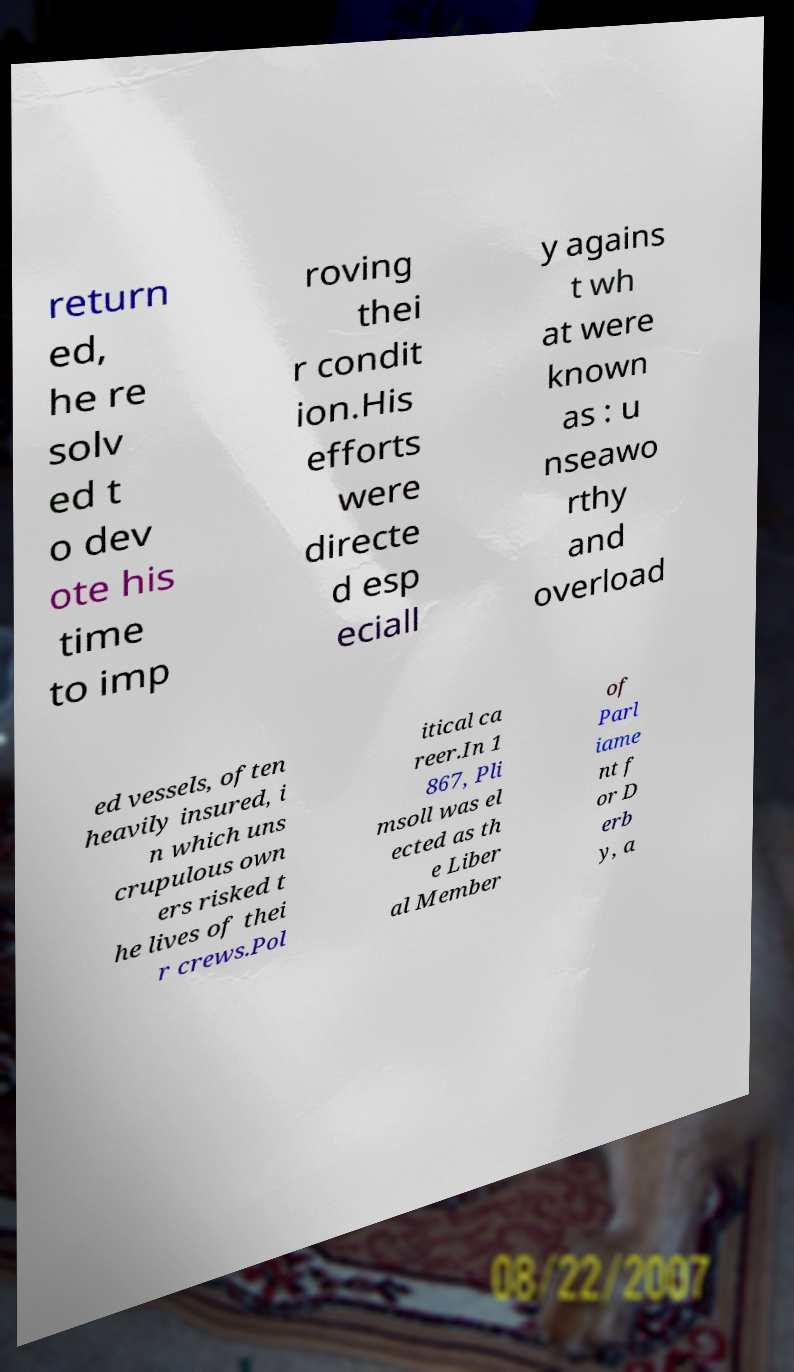I need the written content from this picture converted into text. Can you do that? return ed, he re solv ed t o dev ote his time to imp roving thei r condit ion.His efforts were directe d esp eciall y agains t wh at were known as : u nseawo rthy and overload ed vessels, often heavily insured, i n which uns crupulous own ers risked t he lives of thei r crews.Pol itical ca reer.In 1 867, Pli msoll was el ected as th e Liber al Member of Parl iame nt f or D erb y, a 